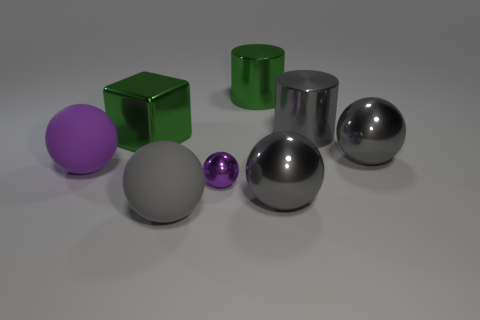Subtract all gray spheres. How many were subtracted if there are1gray spheres left? 2 Subtract all tiny purple shiny spheres. How many spheres are left? 4 Subtract 3 spheres. How many spheres are left? 2 Subtract all cyan blocks. How many purple spheres are left? 2 Subtract all purple balls. How many balls are left? 3 Add 1 green objects. How many objects exist? 9 Subtract all brown spheres. Subtract all purple cubes. How many spheres are left? 5 Subtract all cylinders. How many objects are left? 6 Add 6 small purple shiny objects. How many small purple shiny objects are left? 7 Add 8 blue metallic objects. How many blue metallic objects exist? 8 